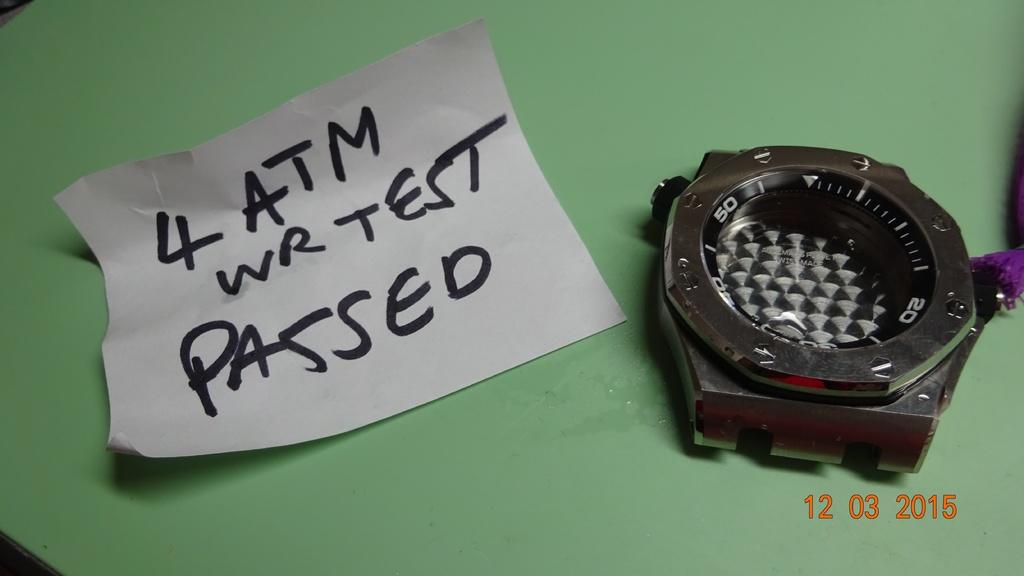What does the note say?
Offer a terse response. 4 atm wr test passed. 